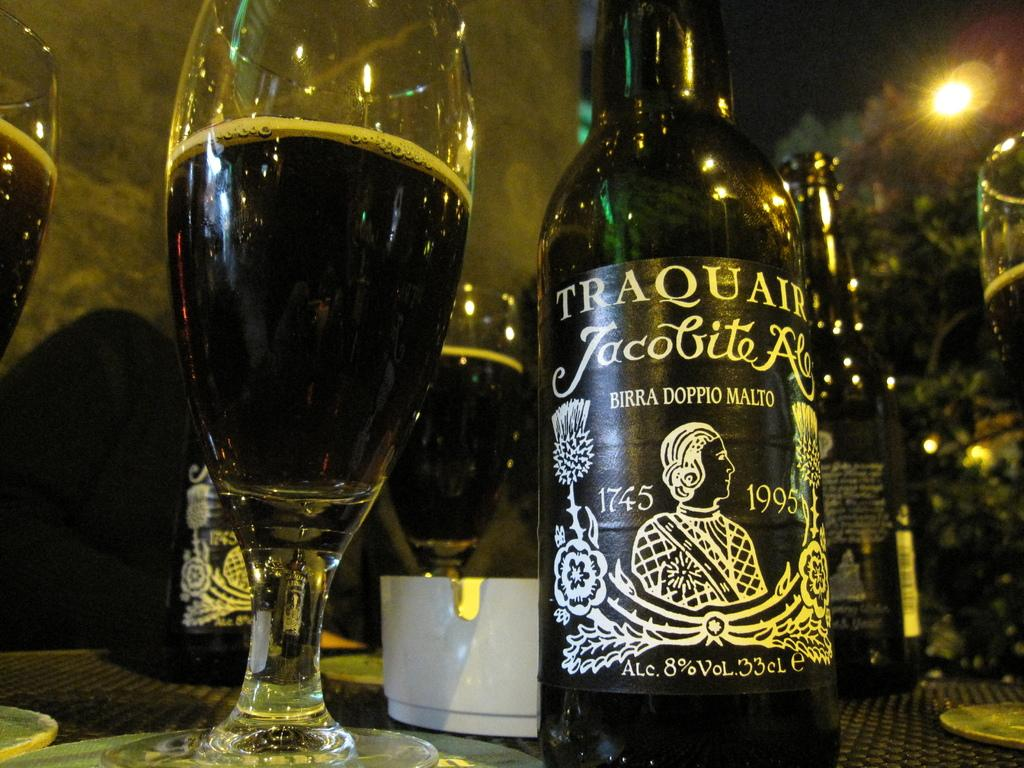Provide a one-sentence caption for the provided image. A bottle of Traquair beer on an outdoors table. 